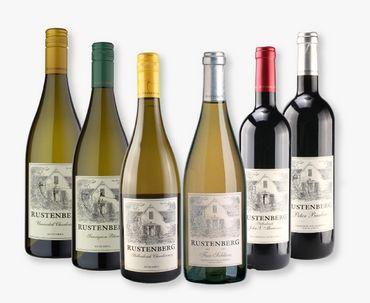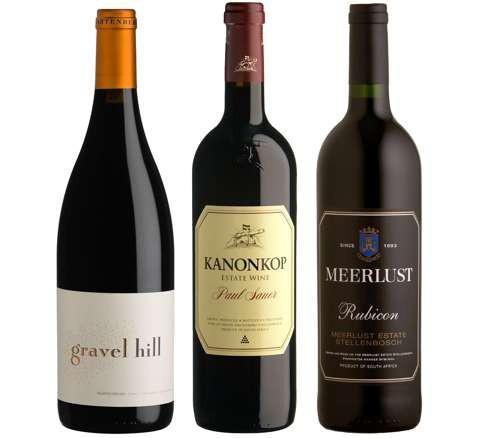The first image is the image on the left, the second image is the image on the right. Assess this claim about the two images: "Each image shows exactly three wine bottles, and no bottles are overlapping.". Correct or not? Answer yes or no. No. The first image is the image on the left, the second image is the image on the right. Considering the images on both sides, is "There are three wine bottles against a plain white background in each image." valid? Answer yes or no. No. 